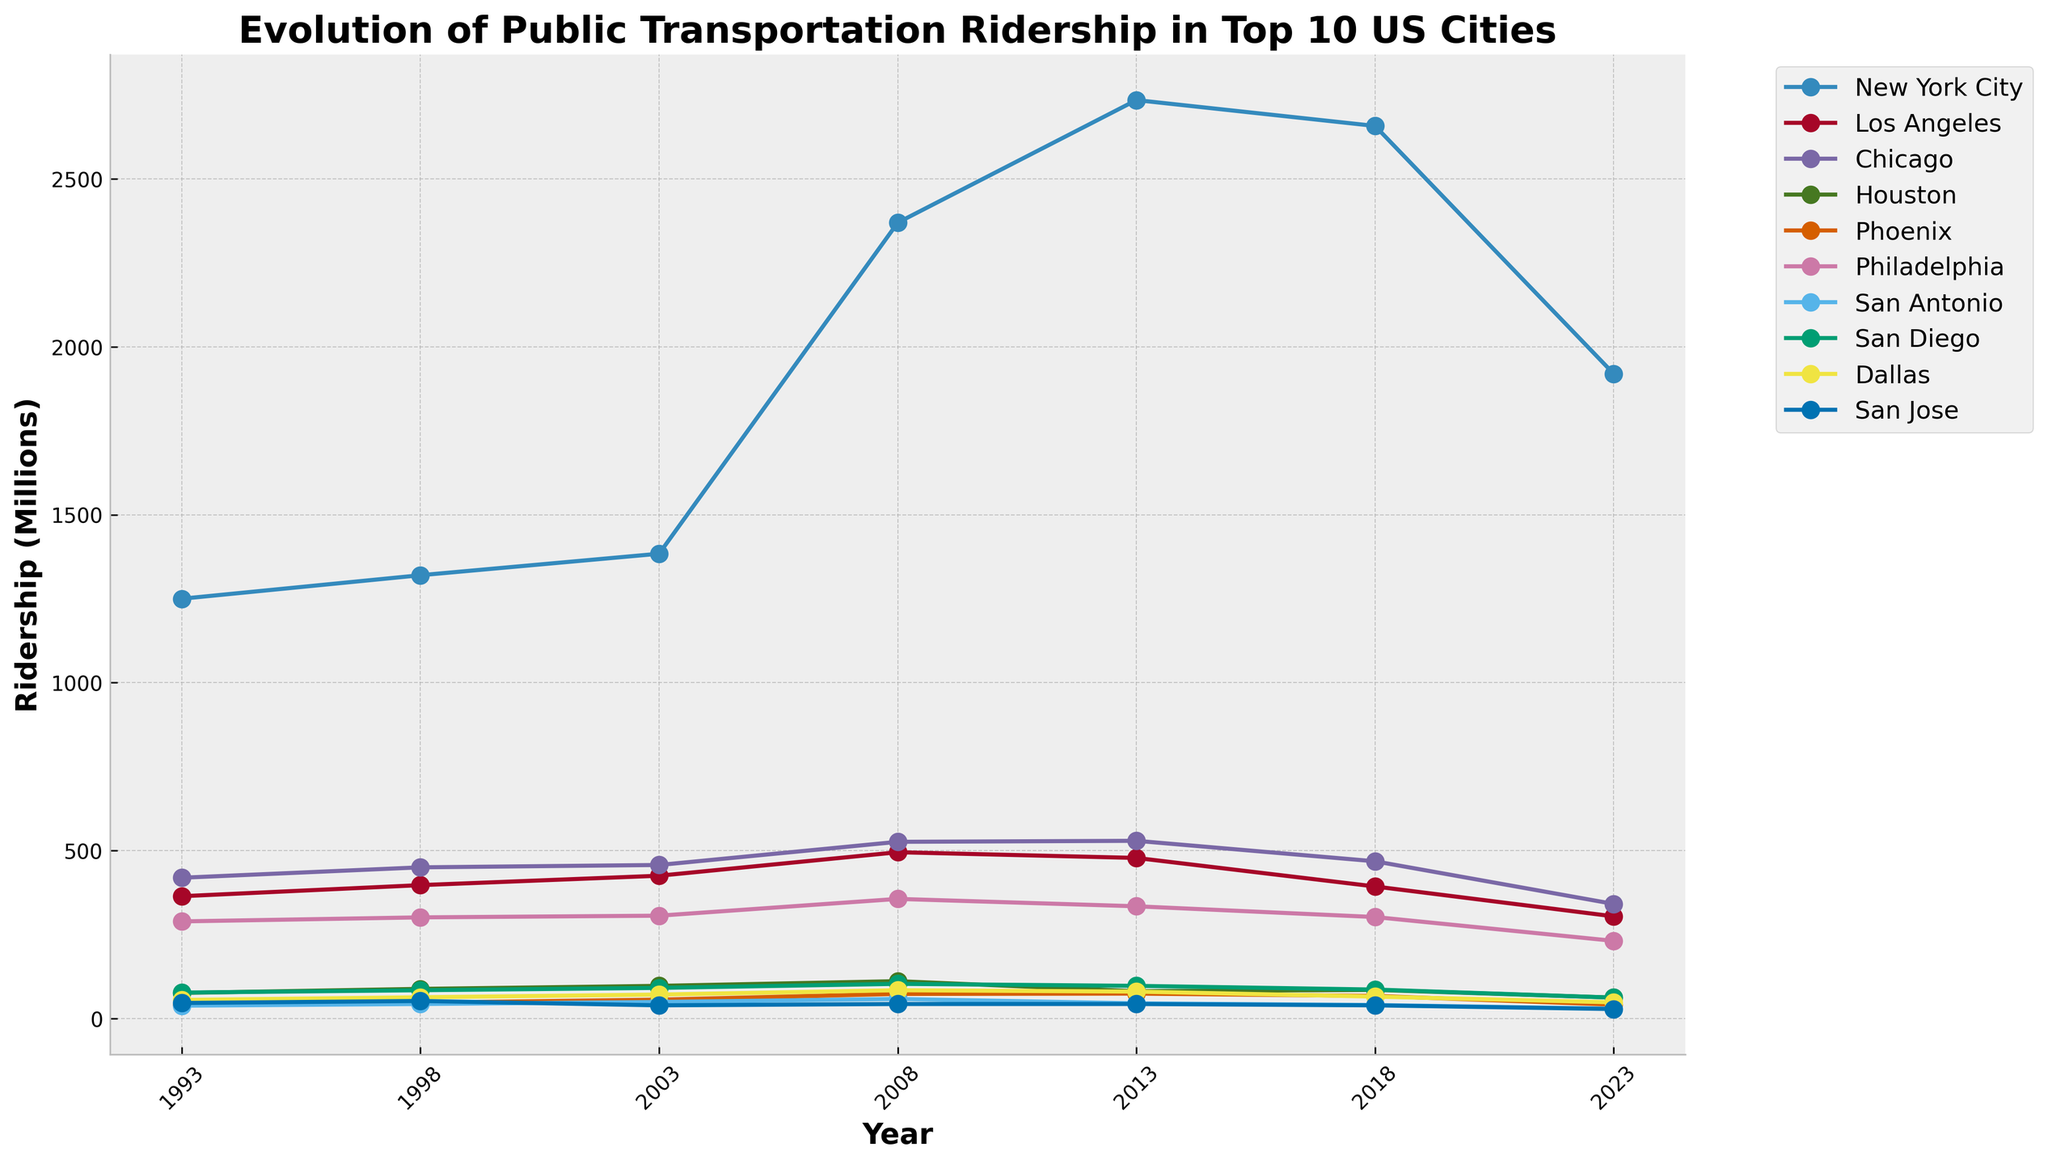What's the overall trend in public transportation ridership in New York City over the past 30 years? The line for New York City shows an increase in ridership from 1993 to 2013, peaking in 2013, followed by a decline from 2013 to 2023.
Answer: Increasing until 2013, then decreasing Which city had the highest ridership in 2023? By looking at the end points of the lines in 2023, New York City has the highest ridership.
Answer: New York City Between 2003 and 2013, did Philadelphia's public transportation ridership increase or decrease? By comparing the values of Philadelphia in 2003 and 2013, the ridership decreased from 306 million to 334 million.
Answer: Decrease What are the top 3 cities with the highest ridership in 2008? Observing the values for ridership in 2008, the top 3 cities are New York City (2370 million), Chicago (526 million), and Los Angeles (495 million).
Answer: New York City, Chicago, Los Angeles How much did San Jose's ridership change from 1993 to 2023? The ridership of San Jose in 1993 was 46 million, and in 2023 it was 28 million, so the change is 46 - 28 = 18 million.
Answer: Decrease by 18 million Which city showed the highest increase in ridership between 1993 and 2008? By comparing the increases for each city from 1993 to 2008, New York City showed the highest increase from 1250 million to 2370 million, which is an increase of 1120 million.
Answer: New York City Is there any city where ridership consistently decreased over the 30-year period? By observing the trend lines, most cities had fluctuations with increases and then decreases, but Philadelphia showed a relatively consistent decrease from 289 million to 231 million.
Answer: Yes, Philadelphia In which year did Los Angeles reach its peak ridership? By examining the trend line for Los Angeles, the peak ridership occurred in 2008 with 495 million.
Answer: 2008 Compare the ridership trends of Houston and Dallas from 1993 to 2023. Which city had a more apparent decline? Both cities had fluctuations, but Dallas showed a more apparent decline from 55 million in 1993 to 48 million in 2023, whereas Houston had peaks and valleys, ending also in a decline.
Answer: Dallas What is the average ridership for San Diego over the 30-year period? San Diego's ridership values are 77, 84, 91, 103, 97, 86, and 62 million. Summing these values gives 600 million, and dividing by 7 (number of data points) results in approximately 85.7 million.
Answer: Approximately 85.7 million 